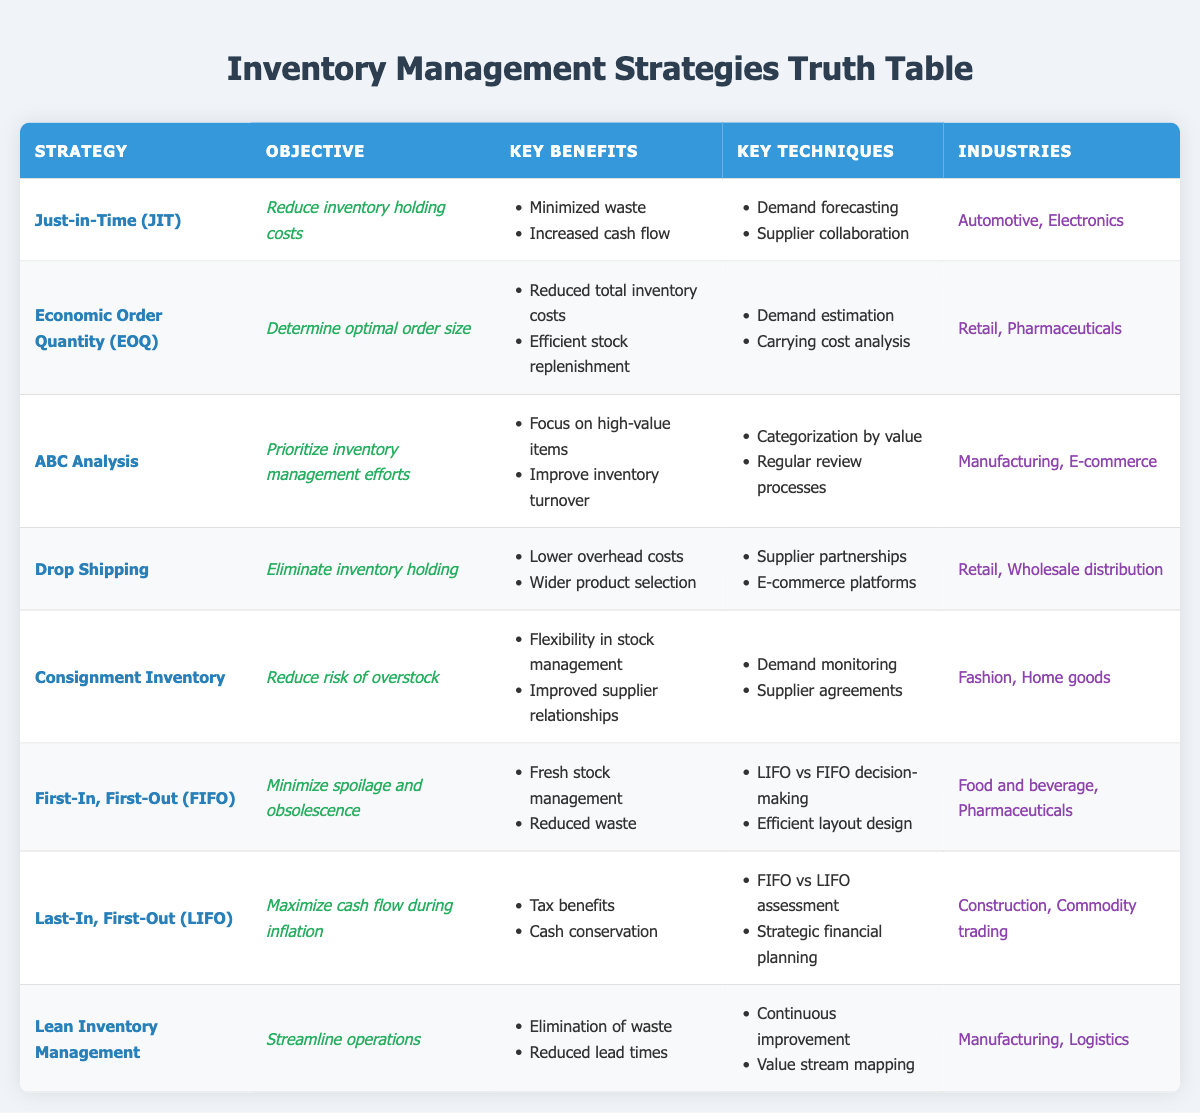What is the objective of the Just-in-Time (JIT) strategy? The objective of the Just-in-Time (JIT) strategy is to reduce inventory holding costs, as stated in the table under the "Objective" column for the JIT strategy.
Answer: Reduce inventory holding costs Which strategy focuses on minimizing waste? The strategy that focuses on minimizing waste is Just-in-Time (JIT), as indicated by its key benefits in the table which includes "Minimized waste."
Answer: Just-in-Time (JIT) How many industries are listed for the Economic Order Quantity (EOQ) strategy? The Economic Order Quantity (EOQ) strategy is listed under two industries: "Retail" and "Pharmaceuticals," which can be observed in the "Industries" column for that strategy.
Answer: 2 Which strategy provides the key techniques of "Continuous improvement" and "Value stream mapping"? The strategy providing "Continuous improvement" and "Value stream mapping" as key techniques is Lean Inventory Management, as those techniques are specifically mentioned for that strategy in the table.
Answer: Lean Inventory Management True or False: ABC Analysis is aimed at maximizing cash flow during inflation. The ABC Analysis is aimed at prioritizing inventory management efforts, not specifically maximizing cash flow during inflation, thus the statement is false.
Answer: False What are the key benefits of Consignment Inventory? The key benefits of Consignment Inventory, as listed in the table, are "Flexibility in stock management" and "Improved supplier relationships."
Answer: Flexibility in stock management, Improved supplier relationships Which strategy is aimed at reducing the risk of overstock? The strategy specifically aimed at reducing the risk of overstock is Consignment Inventory, as indicated by its objective in the corresponding row of the table.
Answer: Consignment Inventory List the key techniques used in the Last-In, First-Out (LIFO) strategy. The key techniques used in the LIFO strategy are "FIFO vs LIFO assessment" and "Strategic financial planning," as shown in the "Key Techniques" column for that strategy.
Answer: FIFO vs LIFO assessment, Strategic financial planning What is the objective of the Lean Inventory Management strategy? The objective of the Lean Inventory Management strategy is to streamline operations, as stated in the table under the "Objective" column for that strategy.
Answer: Streamline operations How does the number of key benefits differ between FIFO and LIFO strategies? The FIFO strategy has two key benefits ("Fresh stock management" and "Reduced waste"), and the LIFO strategy has two key benefits ("Tax benefits" and "Cash conservation"). Since both have the same number (two), the difference is zero.
Answer: 0 